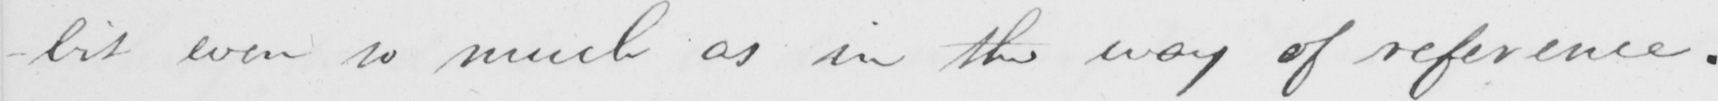What does this handwritten line say? -bit even so much as in the way of reference . 